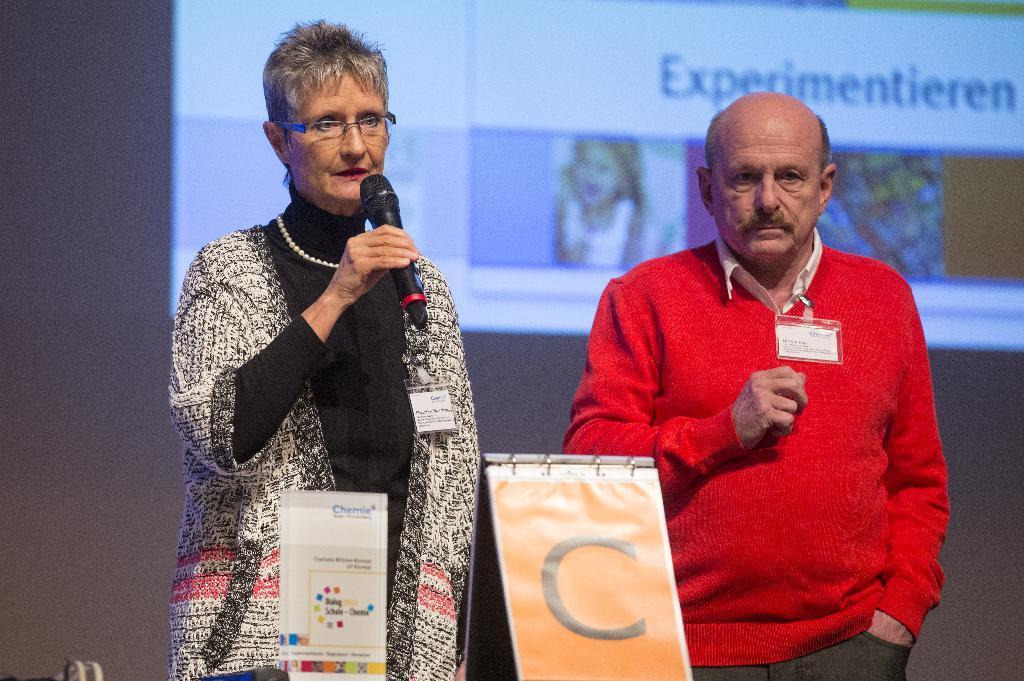Could you give a brief overview of what you see in this image? In the image we can see two persons the woman she is holding the mike. And the man he is standing and back of them there is a screen. 